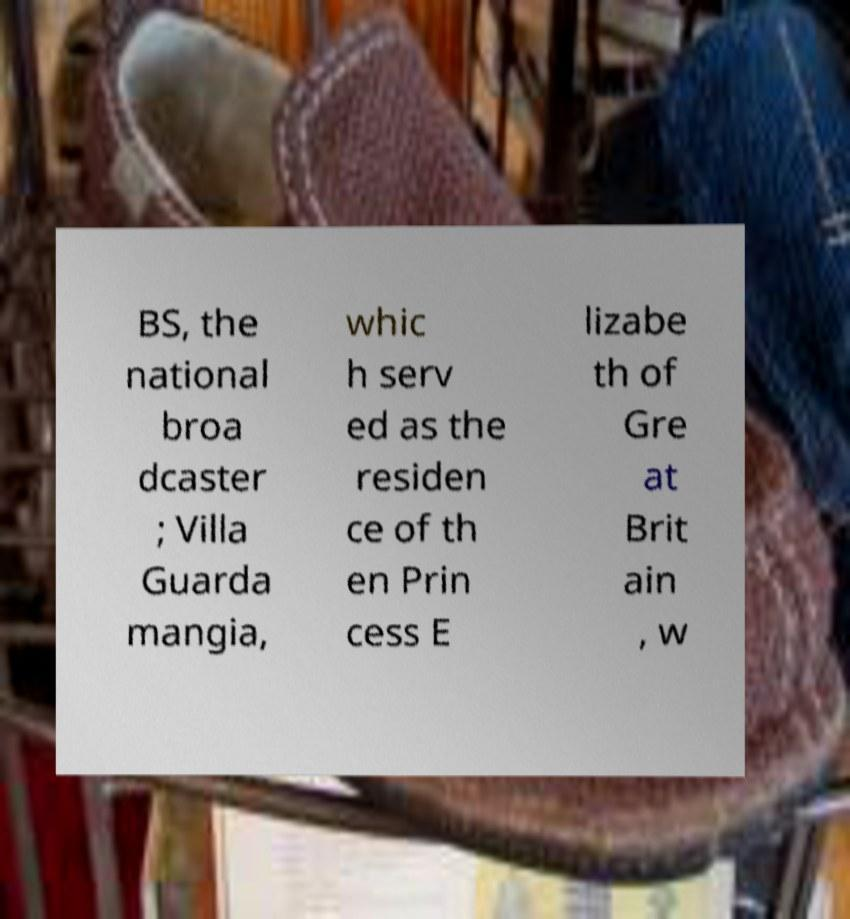There's text embedded in this image that I need extracted. Can you transcribe it verbatim? BS, the national broa dcaster ; Villa Guarda mangia, whic h serv ed as the residen ce of th en Prin cess E lizabe th of Gre at Brit ain , w 